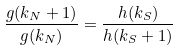Convert formula to latex. <formula><loc_0><loc_0><loc_500><loc_500>\frac { g ( k _ { N } + 1 ) } { g ( k _ { N } ) } = \frac { h ( k _ { S } ) } { h ( k _ { S } + 1 ) }</formula> 